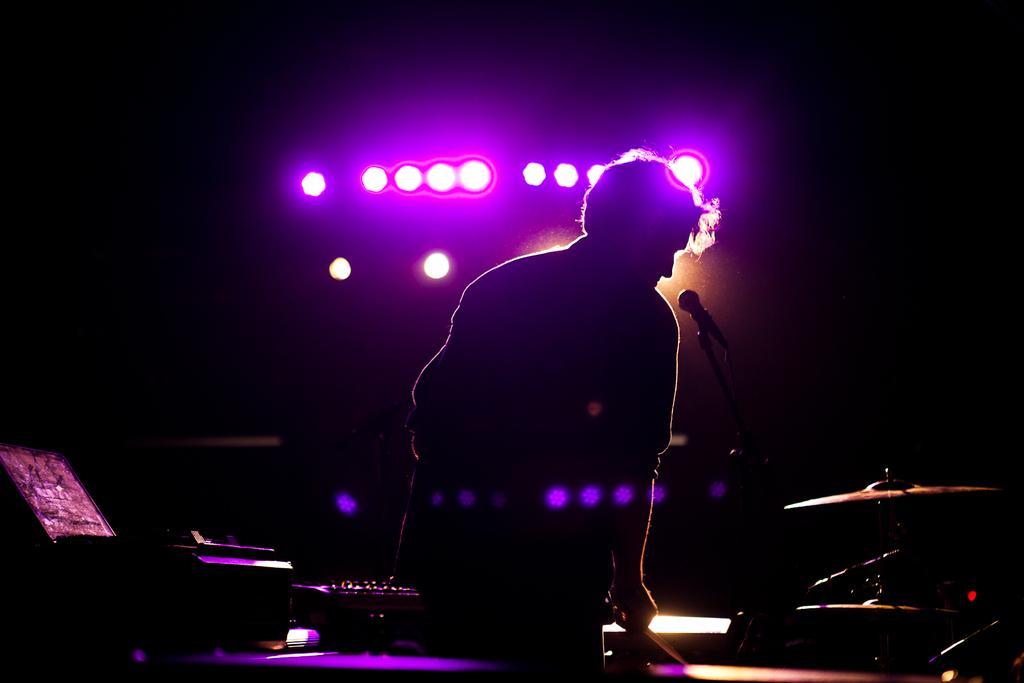In one or two sentences, can you explain what this image depicts? This image is taken in a concert. In this image the background is dark and there are a few lights. In the middle of the image a man is standing and there is a mic. At the bottom of the image there are a few musical instruments. 